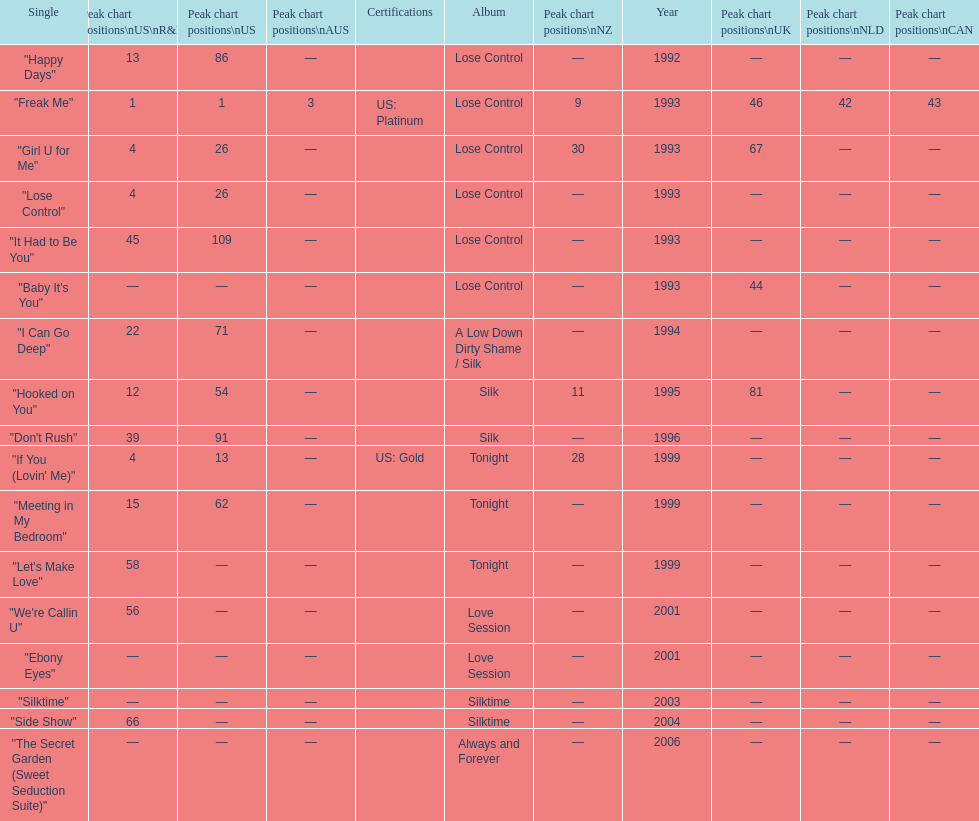Which single is the most in terms of how many times it charted? "Freak Me". 